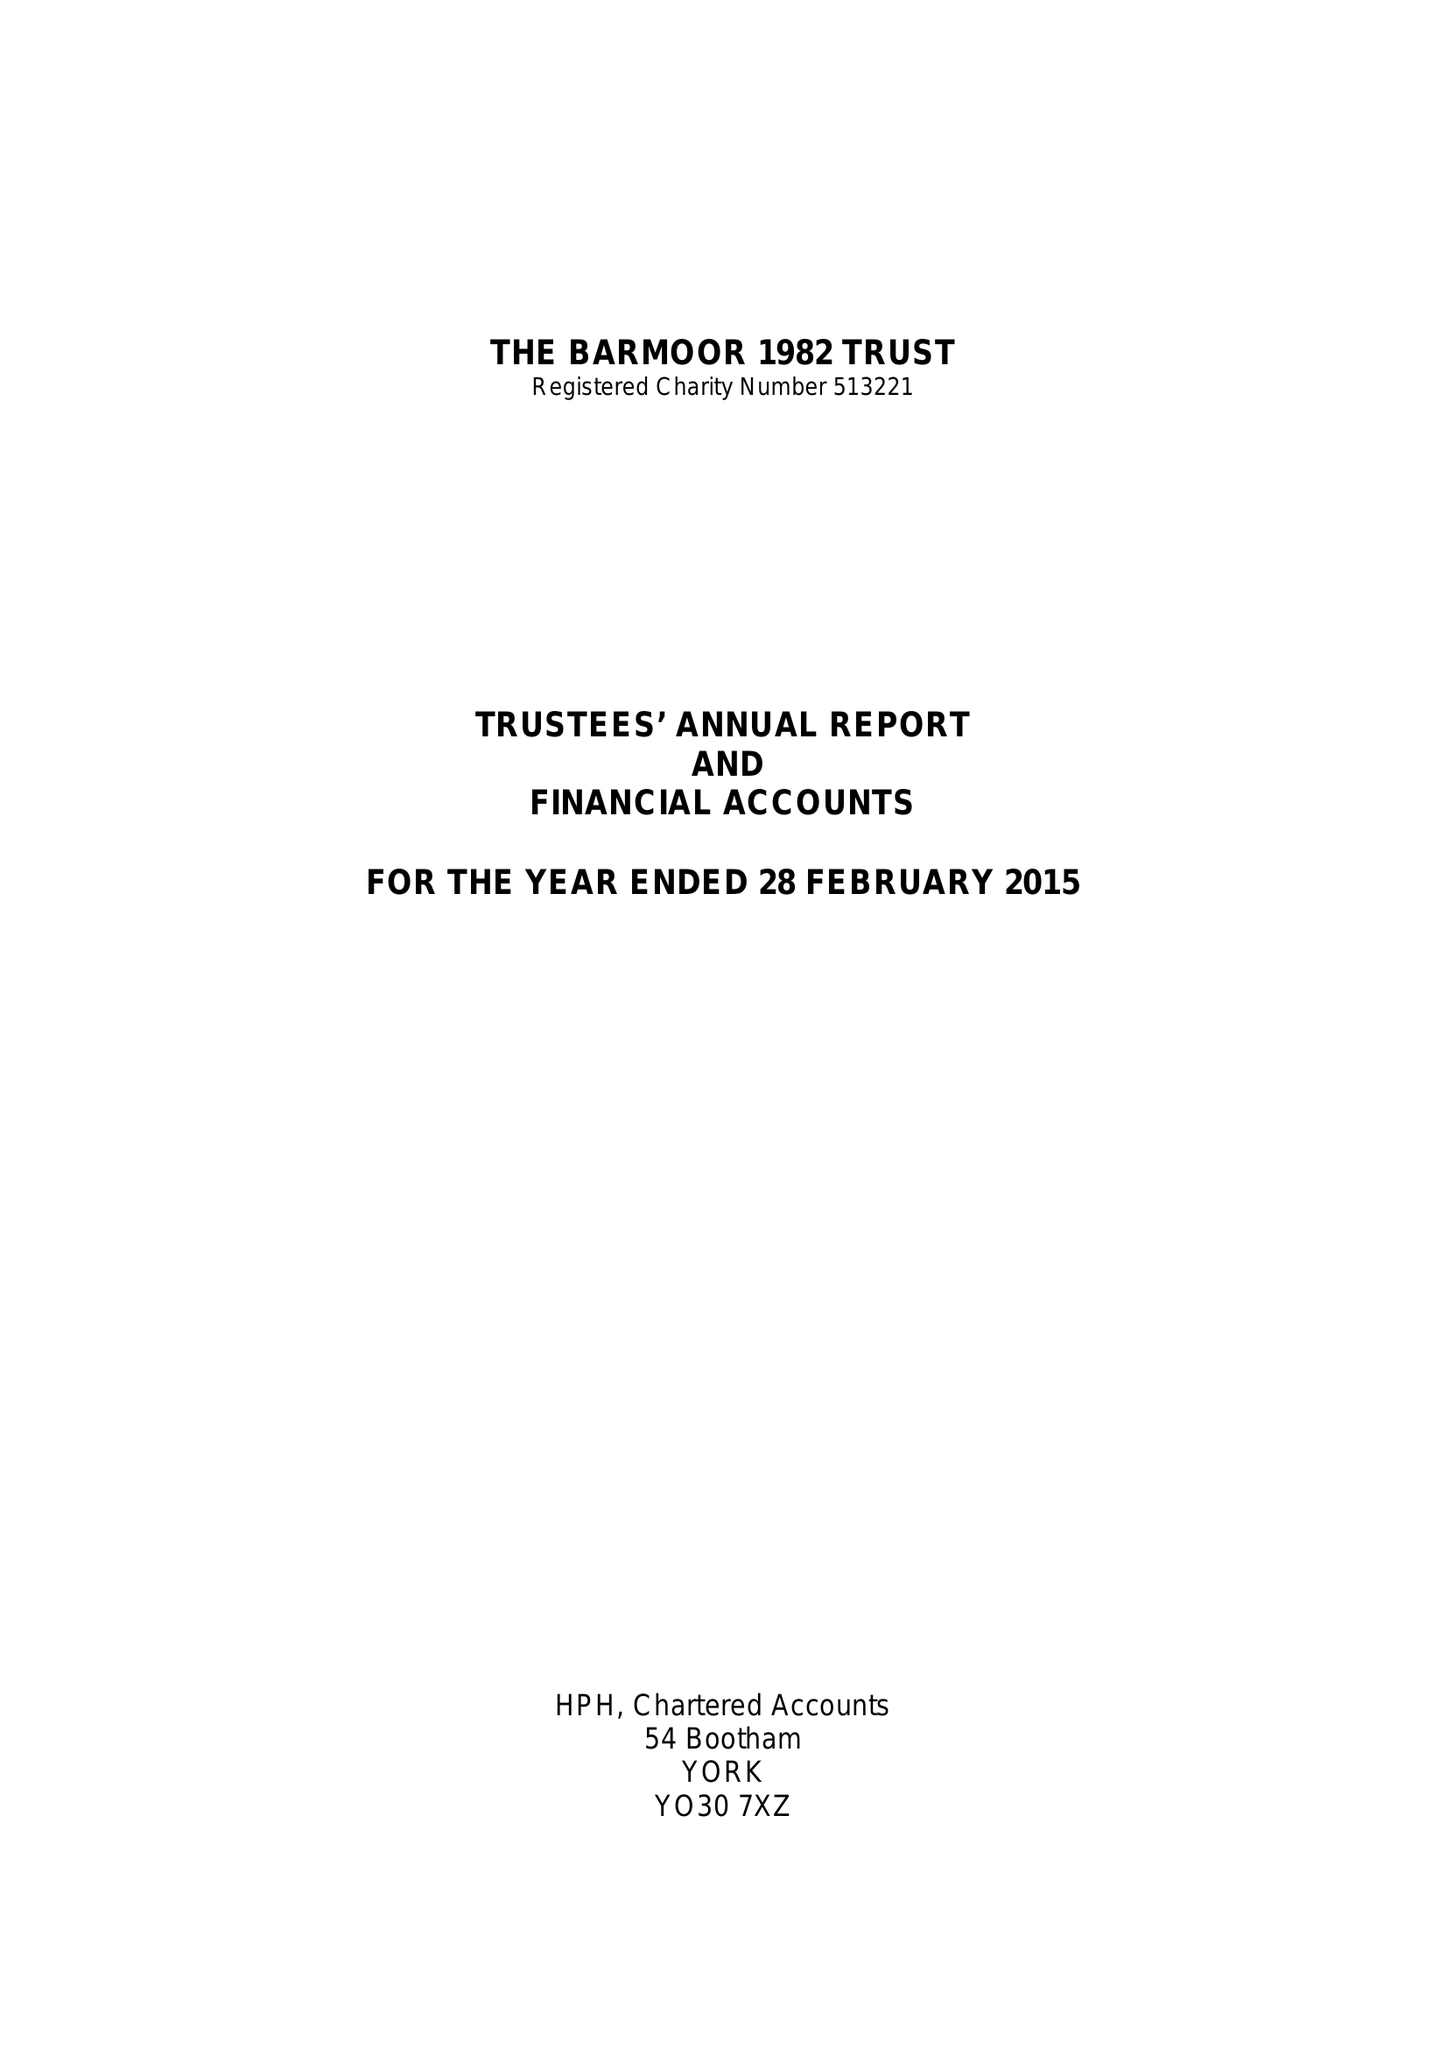What is the value for the report_date?
Answer the question using a single word or phrase. 2015-02-28 